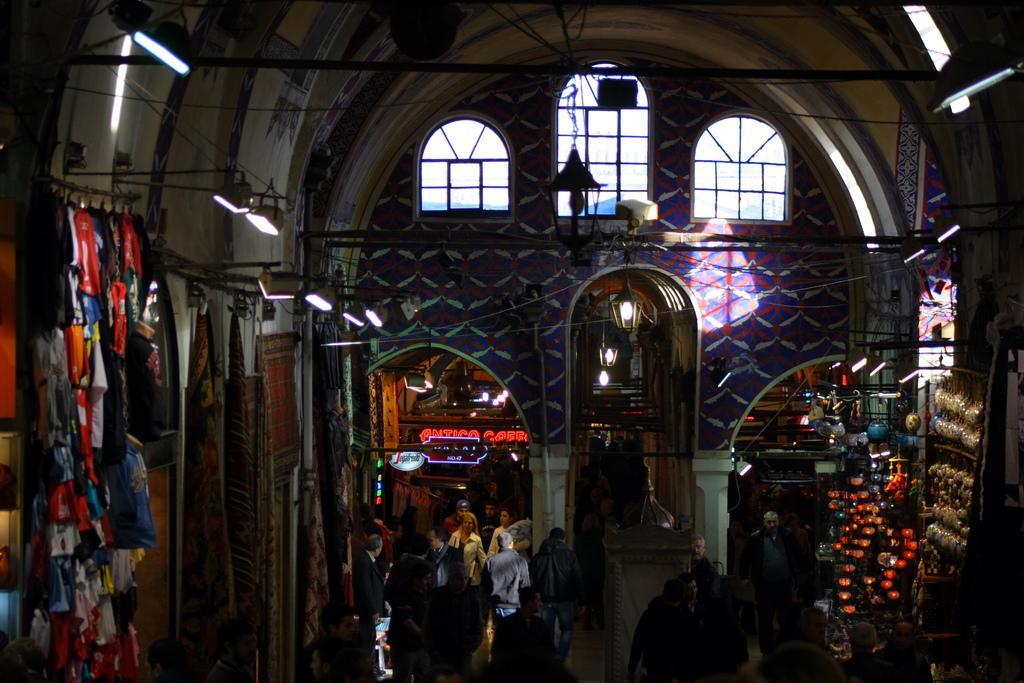Can you describe this image briefly? There are people, it seems like lanterns, racks and other items at the bottom side of the image, there are lamps, bamboos and a bell at the top side, there are arches and windows in the background, it seems like clothes on the left side. 